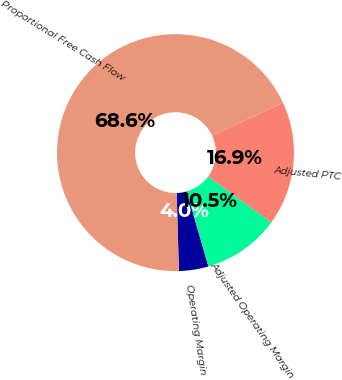Convert chart. <chart><loc_0><loc_0><loc_500><loc_500><pie_chart><fcel>Operating Margin<fcel>Adjusted Operating Margin<fcel>Adjusted PTC<fcel>Proportional Free Cash Flow<nl><fcel>4.03%<fcel>10.48%<fcel>16.94%<fcel>68.55%<nl></chart> 